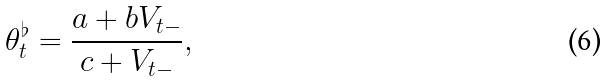<formula> <loc_0><loc_0><loc_500><loc_500>\theta ^ { \flat } _ { t } = \frac { a + b V _ { t - } } { c + V _ { t - } } ,</formula> 